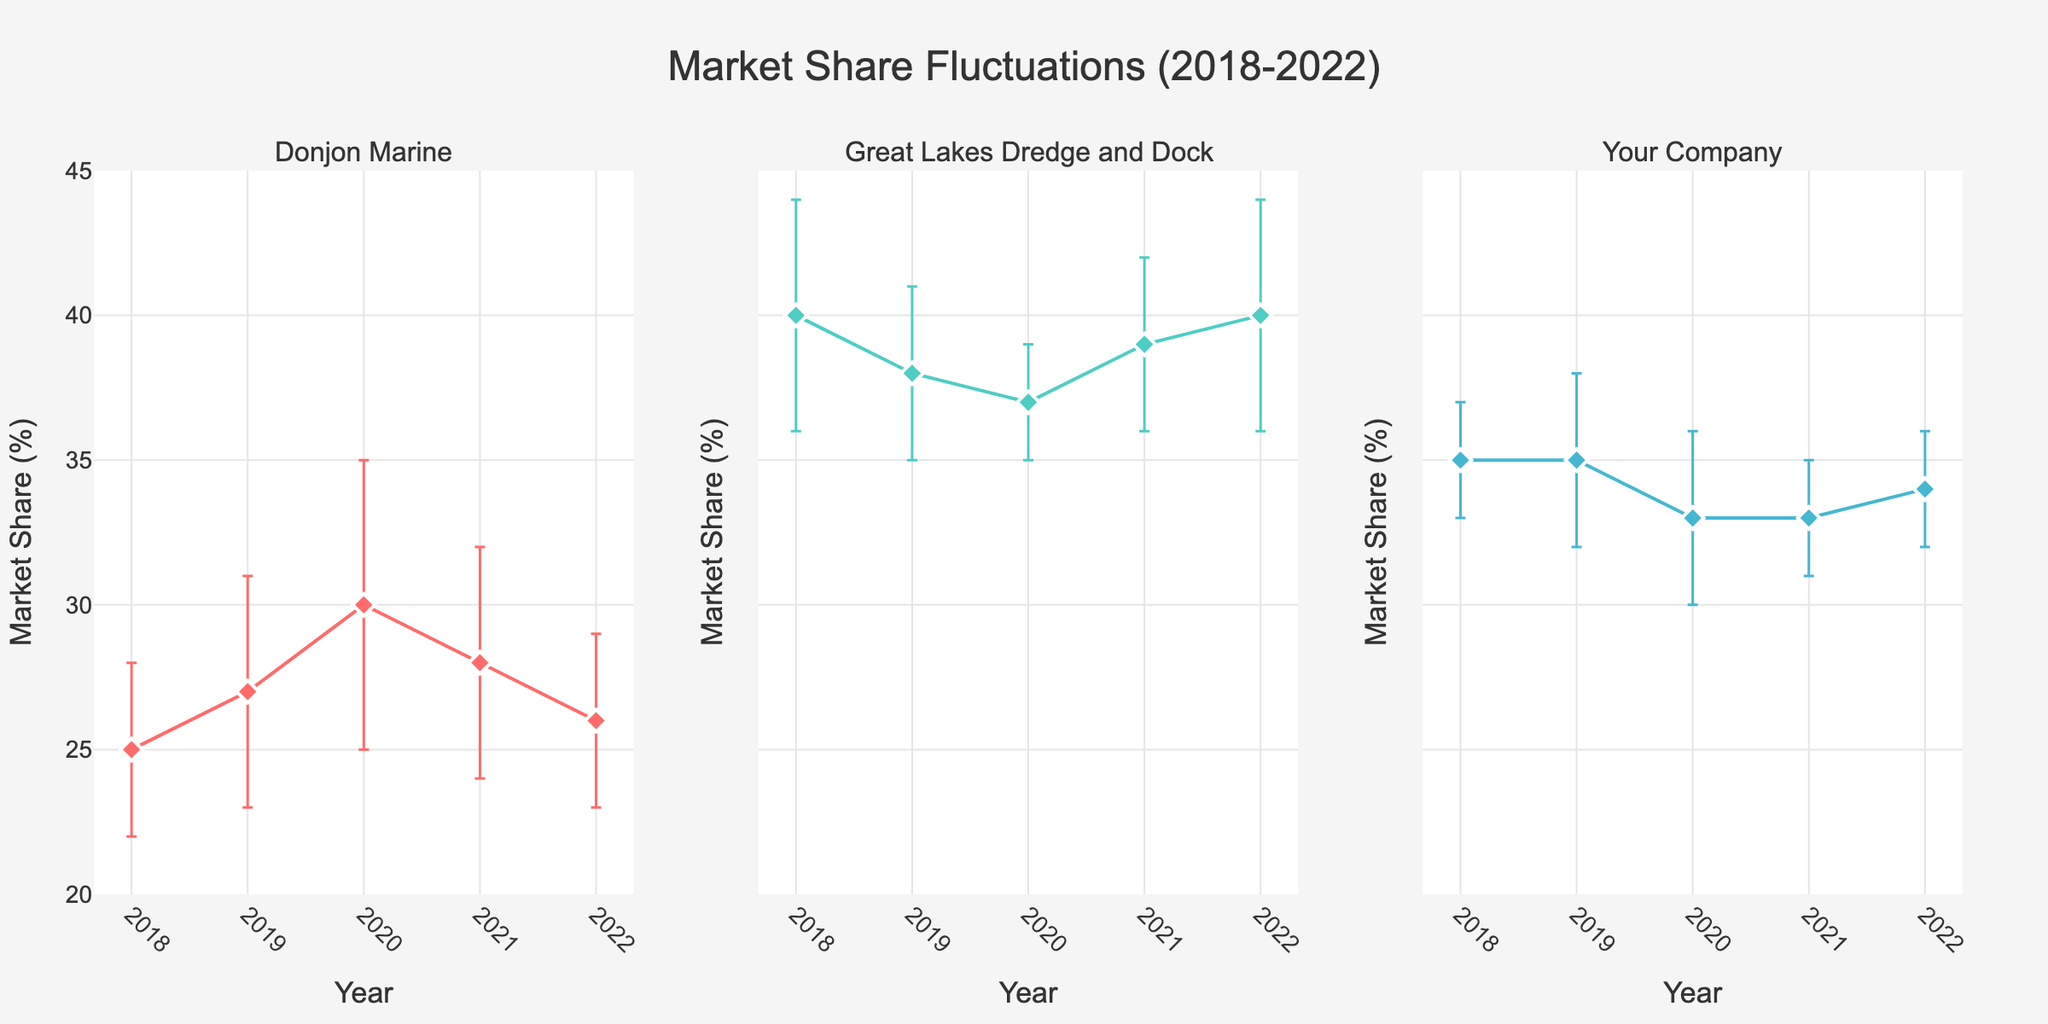What's the title of the figure? The title of the figure is displayed at the top center of the plot, which reads "Market Share Fluctuations (2018-2022)."
Answer: Market Share Fluctuations (2018-2022) How many years of data are shown in the figure for each company? The x-axis for each subplot shows data from 2018 to 2022, so there are 5 years of data for each company.
Answer: 5 What is the highest market share value for any company and in what year? In the subplot for Great Lakes Dredge and Dock, the market share peaks at 40% in the years 2018 and 2022.
Answer: 40% in 2018 and 2022 Compare the market share of Donjon Marine and Great Lakes Dredge and Dock in 2019. Which one had a higher percentage, and by how much? In 2019, Donjon Marine's market share was 27%, while Great Lakes Dredge and Dock had 38%. To find out the difference, subtract 27 from 38, giving 11%.
Answer: Great Lakes Dredge and Dock by 11% Which company exhibited the largest range in market share values over the five-year period? The range is calculated as the difference between the maximum and minimum market share values for each company. Donjon Marine's market share varied from a minimum of 25% to a maximum of 30%, giving a range of 5%. Great Lakes Dredge and Dock varied from 37% to 40%, resulting in a range of 3%. Your Company varied from 33% to 35%, resulting in a range of 2%. Therefore, Donjon Marine exhibited the largest range.
Answer: Donjon Marine What is the average market share of "Your Company" over the five years? The market share for "Your Company" over the five years is 35, 35, 33, 33, and 34. Sum these values: (35 + 35 + 33 + 33 + 34) = 170. Divide by 5 to get the average: 170 / 5 = 34.
Answer: 34% Considering the error bars, which year shows the most uncertain market share for Donjon Marine? The length of the error bars indicates the uncertainty. For Donjon Marine, the error values are 3 in 2018, 4 in 2019, 5 in 2020, 4 in 2021, and 3 in 2022. The largest error bar is in 2020, with a value of 5.
Answer: 2020 In which year did "Your Company" experience a market share decrease, and by what percentage did it decrease? Comparing the market share of "Your Company," the only decrease happened between 2019 and 2020, from 35% to 33%, a decrease of 2%.
Answer: 2020 by 2% Which company had a generally increasing trend in market share from 2018 to 2020? Observing the trend lines, Donjon Marine shows an increase from 25% in 2018 to 30% in 2020, indicating a generally increasing trend during this period.
Answer: Donjon Marine What was the difference in market share between the highest and lowest market shares for Great Lakes Dredge and Dock in 2020? In 2020, the market share for Great Lakes Dredge and Dock is given as 37% with an error margin of ±2%. Hence, the maximum possible market share is 37 + 2 = 39%, and the minimum possible is 37 - 2 = 35%. The difference is 39% - 35% = 4%.
Answer: 4% 